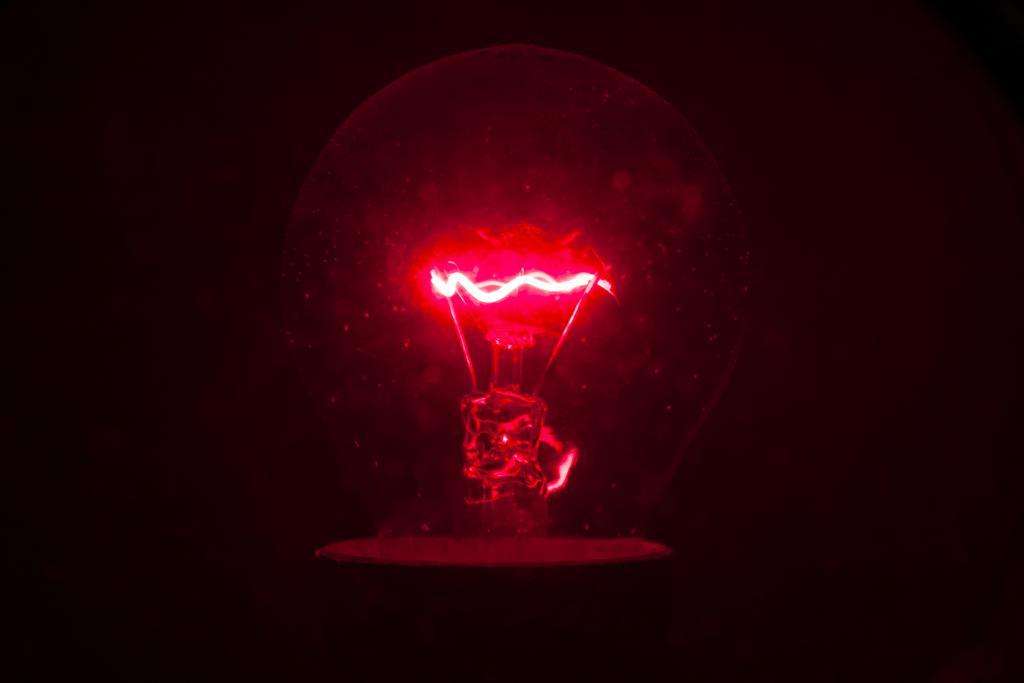What object is present in the image? There is a bulb in the image. What is the color or tone of the background in the image? The background of the image is dark. What type of soup is being served in the can in the image? There is no can or soup present in the image; it only features a bulb. What form does the bulb take in the image? The bulb is in its typical form, as it is an object with a specific design and function. 